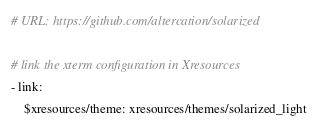Convert code to text. <code><loc_0><loc_0><loc_500><loc_500><_YAML_># URL: https://github.com/altercation/solarized

# link the xterm configuration in Xresources
- link:
    $xresources/theme: xresources/themes/solarized_light

</code> 